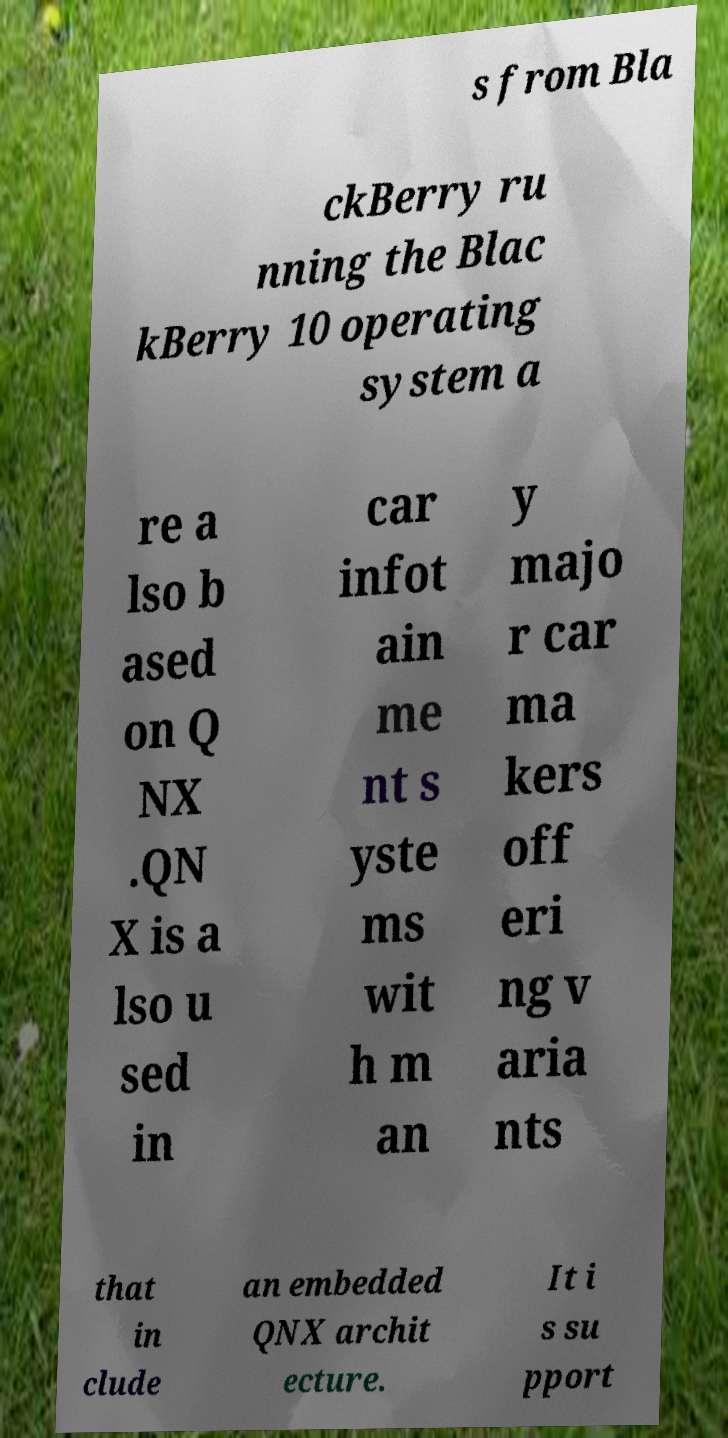Could you extract and type out the text from this image? s from Bla ckBerry ru nning the Blac kBerry 10 operating system a re a lso b ased on Q NX .QN X is a lso u sed in car infot ain me nt s yste ms wit h m an y majo r car ma kers off eri ng v aria nts that in clude an embedded QNX archit ecture. It i s su pport 